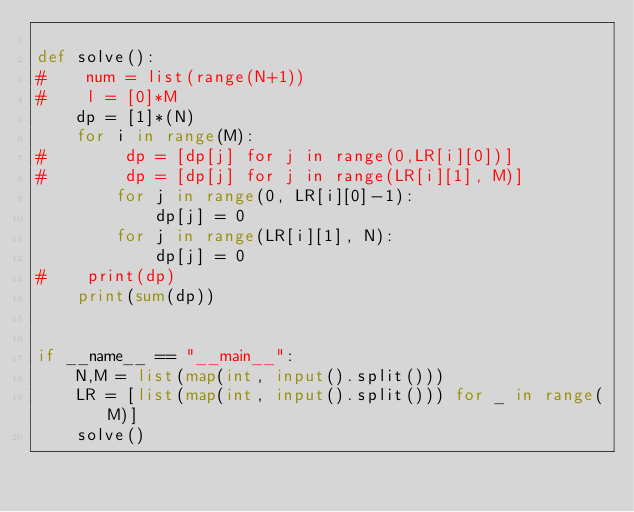<code> <loc_0><loc_0><loc_500><loc_500><_Python_>
def solve():
#    num = list(range(N+1))
#    l = [0]*M
    dp = [1]*(N)
    for i in range(M):
#        dp = [dp[j] for j in range(0,LR[i][0])]
#        dp = [dp[j] for j in range(LR[i][1], M)]
        for j in range(0, LR[i][0]-1):
            dp[j] = 0
        for j in range(LR[i][1], N):
            dp[j] = 0
#    print(dp)
    print(sum(dp))


if __name__ == "__main__":
    N,M = list(map(int, input().split()))
    LR = [list(map(int, input().split())) for _ in range(M)]
    solve()  
</code> 